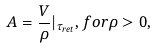<formula> <loc_0><loc_0><loc_500><loc_500>A = \frac { V } { \rho } | _ { \tau _ { r e t } } , f o r \rho > 0 ,</formula> 